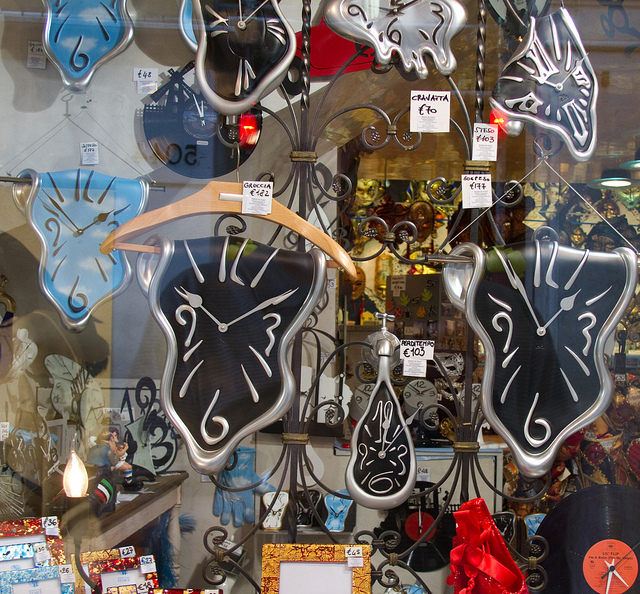Read and extract the text from this image. 3 2 6 12 3 9 12 9 12 103 CRAVATTA 50 6 3 6 3 11 9 6 6 2 3 12 11 3 6 9 